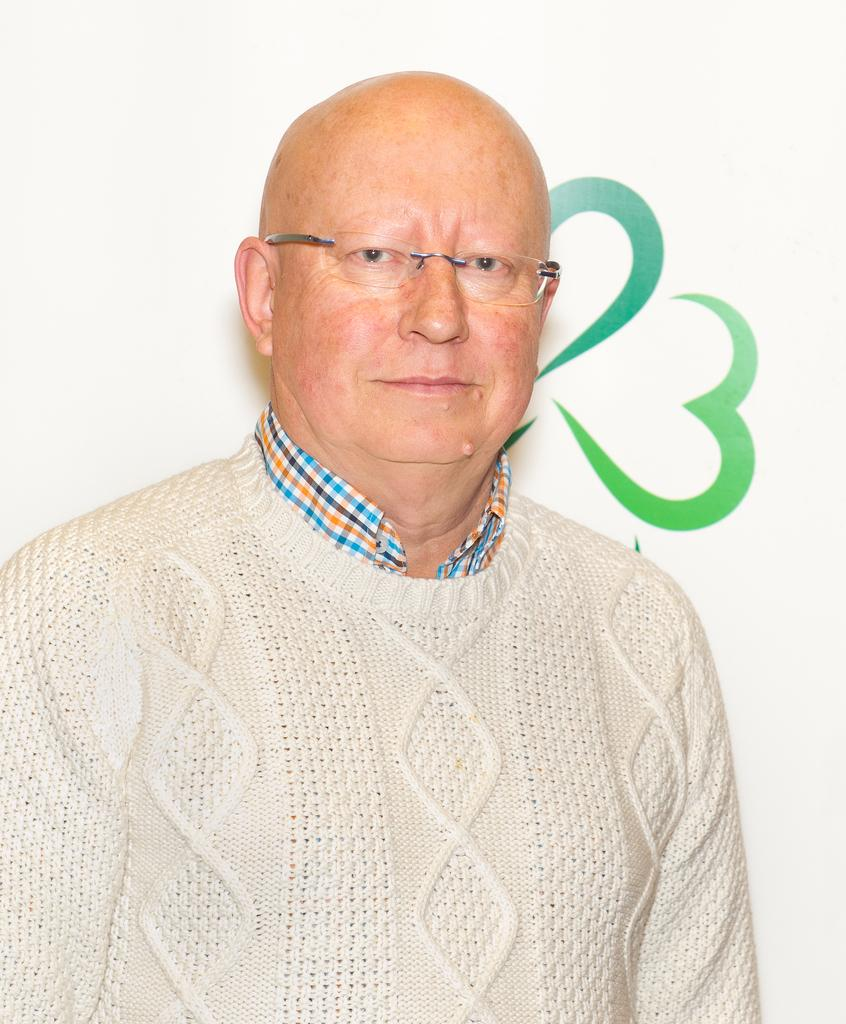Who is the main subject in the image? There is a man in the image. What is the man wearing? The man is wearing a white jacket and spectacles. What is the man's facial expression in the image? The man is smiling. What is the man doing in the image? The man is giving a pose for the picture. What can be seen in the background of the image? There is a green color painting on a white surface in the background. What type of cake is being served in the image? There is no cake present in the image; it features a man posing for a picture. What degree does the man hold, as seen in the image? There is no indication of the man's degree or qualifications in the image. 